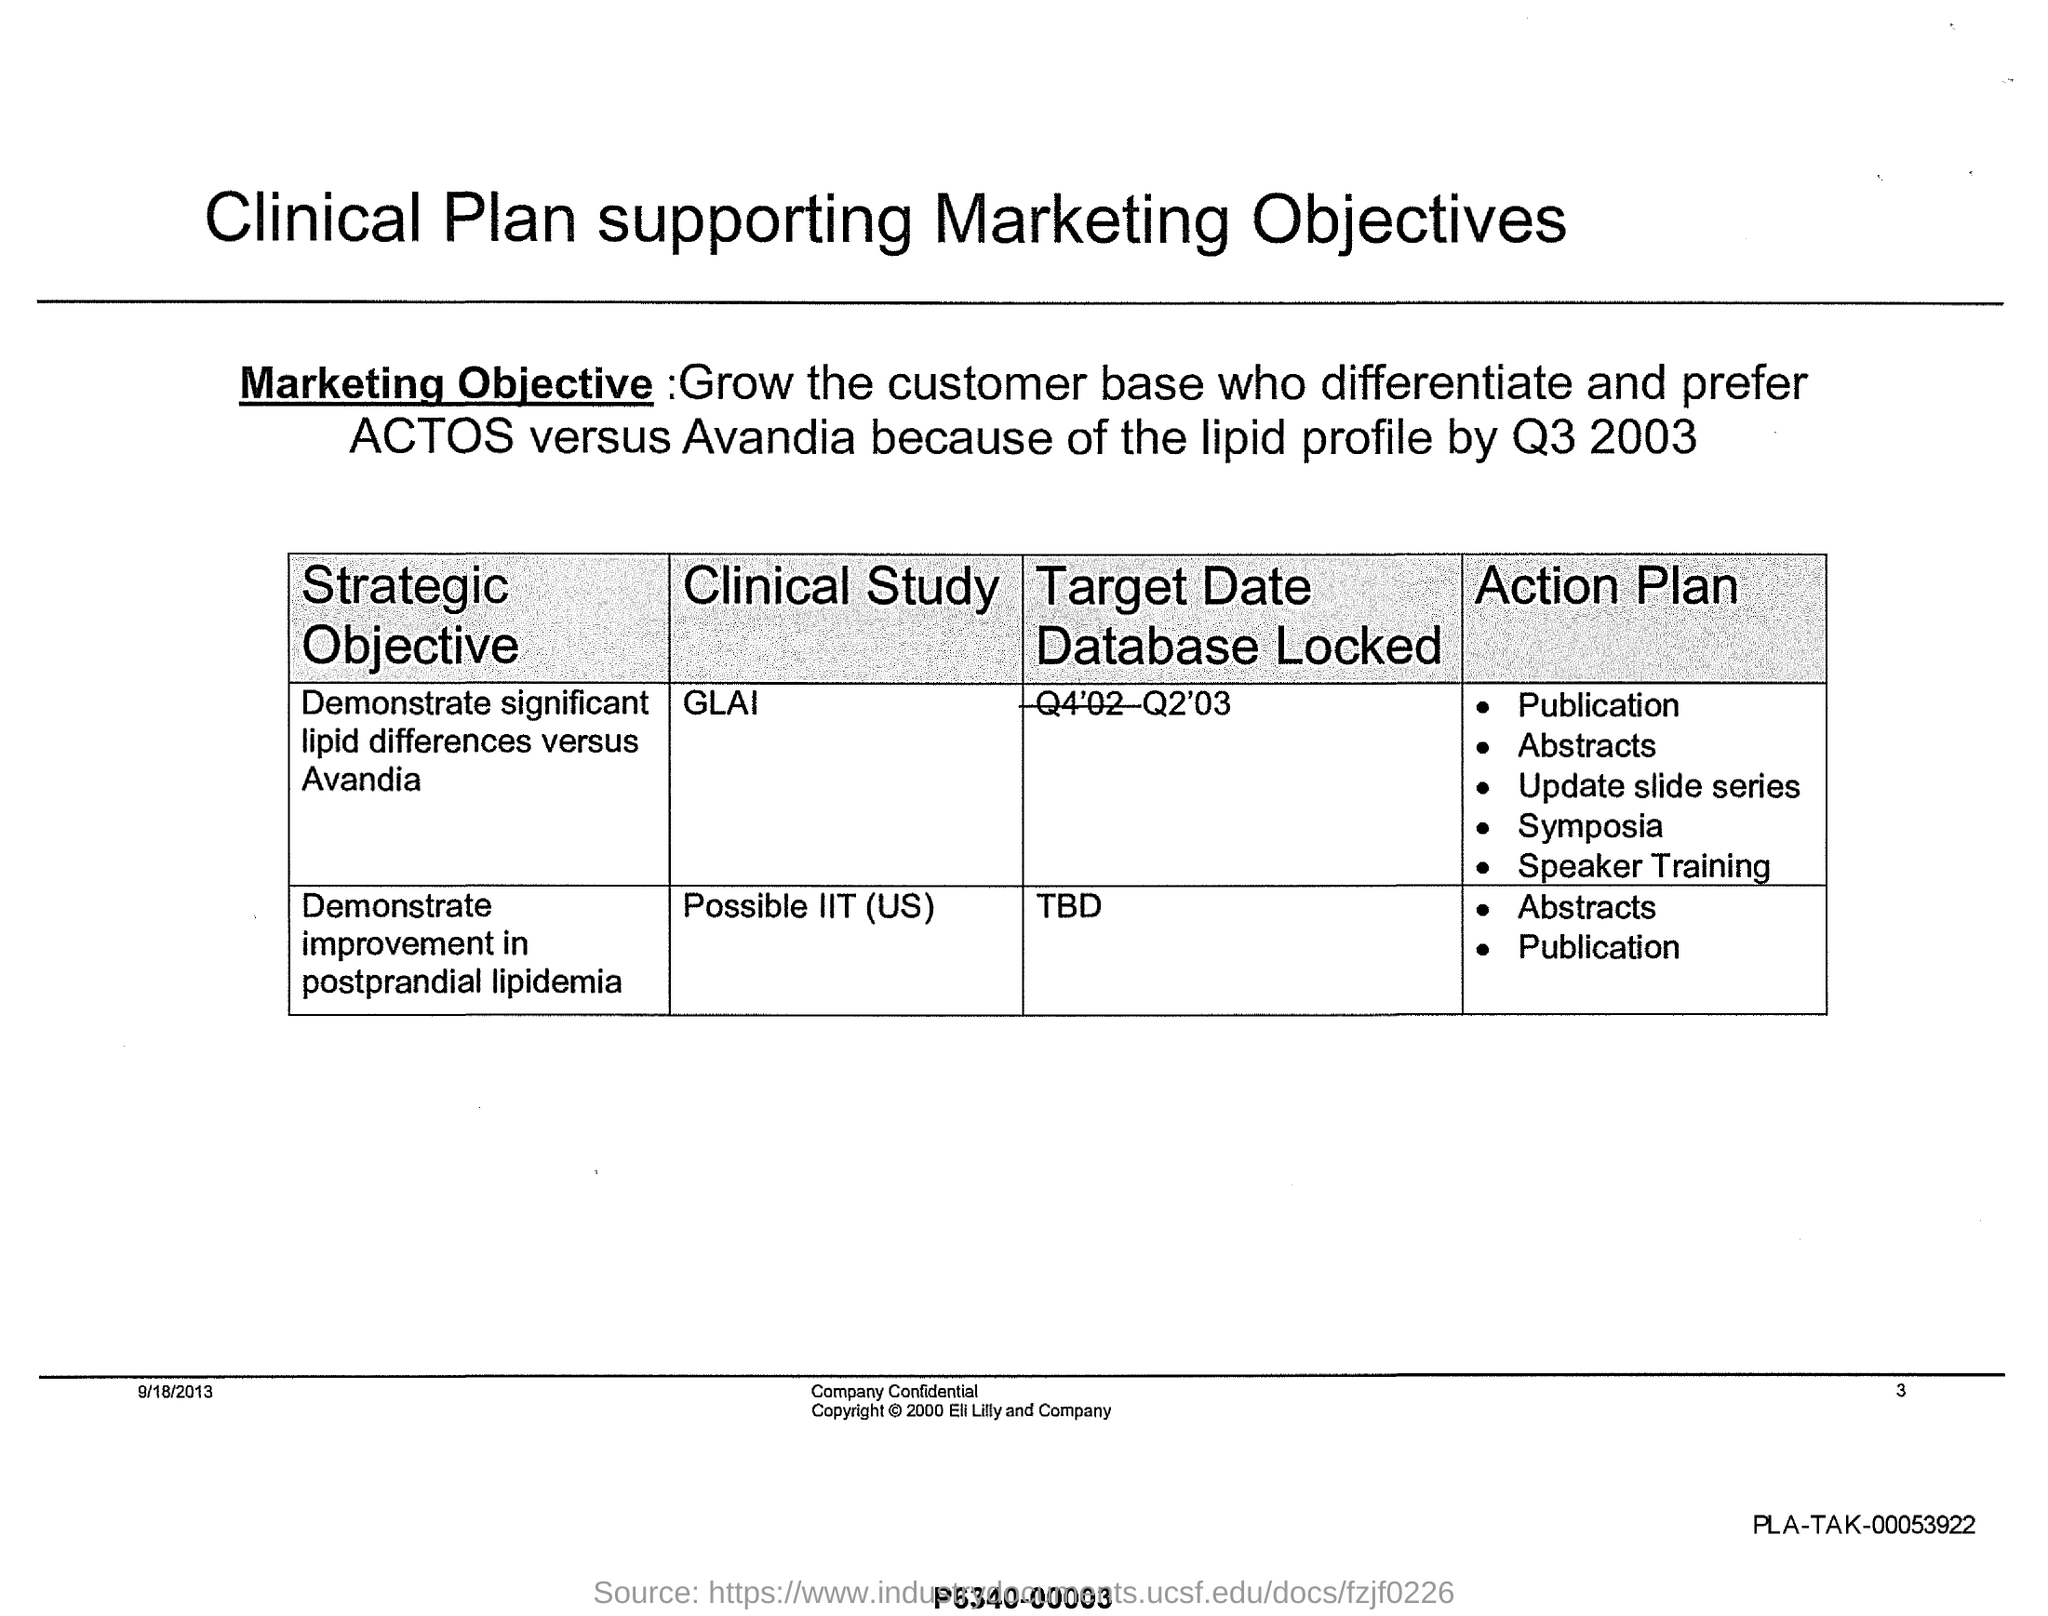Which clinical study has target date database locked as Q2'03?
Keep it short and to the point. Glai. What is the strategic objective of the Clinical study 'GLAI'?
Your response must be concise. Demonstrate significant lipid differences versus avandia. What is the strategic objective of the Clinical study 'Possible IIT (US)'?
Your answer should be compact. Demonstrate improvement in postprandial lipidemia. What is the date mentioned in this document?
Ensure brevity in your answer.  9/18/2013. What is the page no mentioned in this document?
Your answer should be very brief. 3. What is the target date database locked for the clinical study 'Possible IIT (US)'?
Your answer should be compact. Tbd. 